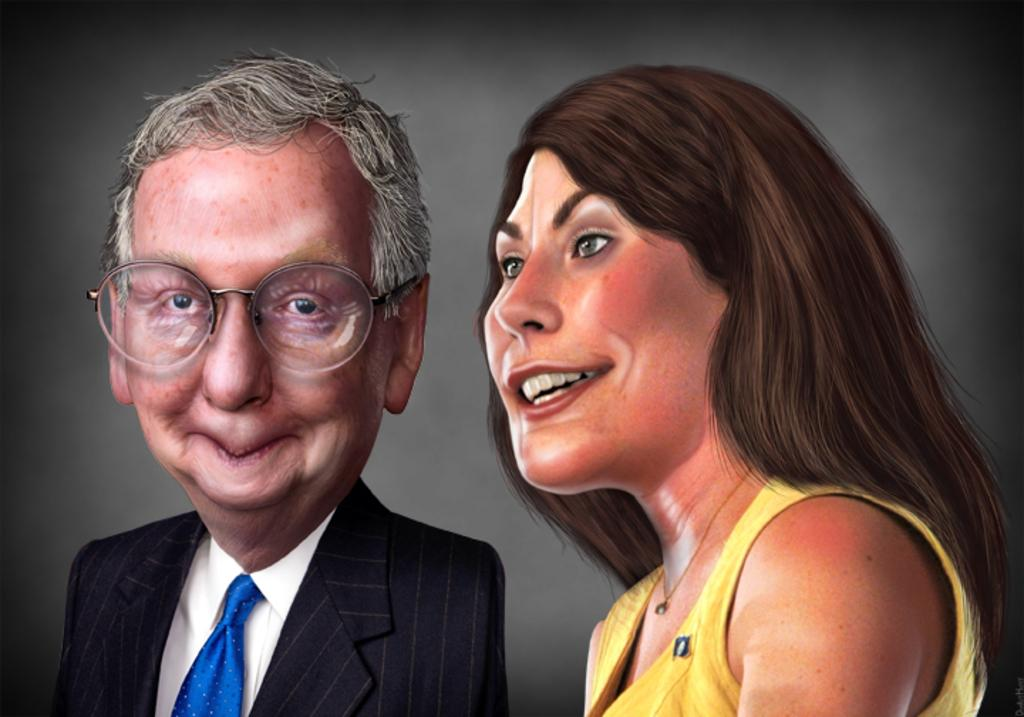What is depicted in the image? The image contains a picture of a man and a woman. Can you describe the style of the picture? The picture appears to be a caricature. What type of motion can be seen in the image? There is no motion present in the image, as it is a static picture of a man and a woman. How many cushions are visible in the image? There are no cushions present in the image. 